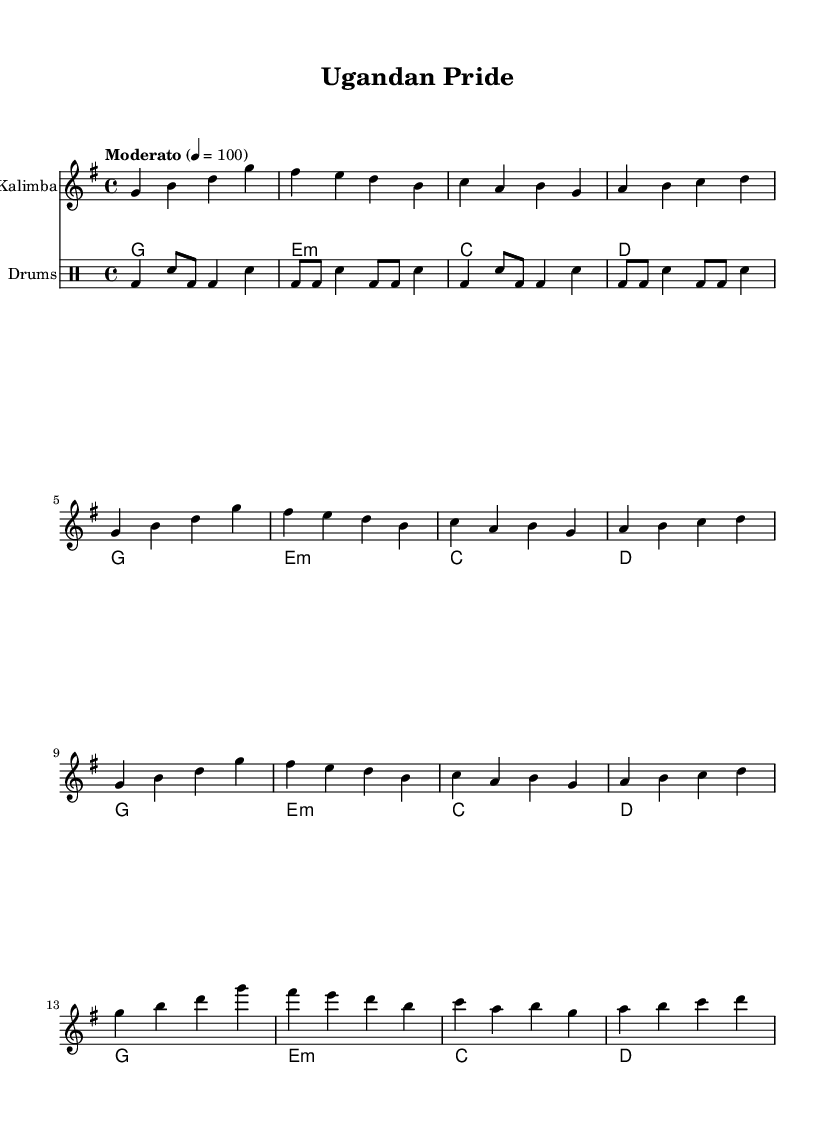What is the key signature of this music? The key signature shown is one sharp, which indicates that the piece is in G major.
Answer: G major What is the time signature of this music? The time signature indicated is four beats per measure, shown as 4/4 at the beginning of the piece.
Answer: 4/4 What is the tempo marking of this piece? The tempo marking states "Moderato," indicating a moderate speed, alongside the metronome marking of 100 beats per minute.
Answer: Moderato How many measures are in the introduction section? By counting the groups of notes, there are four measures in the introduction section of the kalimba part.
Answer: 4 Which instrument plays the main melody? The main melody is played by the kalimba, which is indicated as the instrument for the first staff in the score structure.
Answer: Kalimba What type of chords accompany the kalimba? The chords listed in the chord names section are labeled as conventional triads, which typical for many folk and traditional tracks, specifically indicating G, E minor, C, and D.
Answer: Conventional triads What rhythmic pattern is used for the drum part? The drum part presents a variation of bass drum and snare patterns that establish a supportive rhythm, showing a structured beat throughout the measure.
Answer: Structured beat 